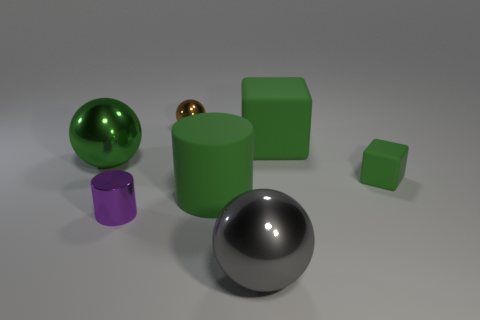There is a large matte thing behind the small green block; what color is it?
Give a very brief answer. Green. What material is the ball in front of the big shiny thing that is behind the green rubber cylinder?
Ensure brevity in your answer.  Metal. Are there any metallic cylinders of the same size as the brown ball?
Ensure brevity in your answer.  Yes. What number of things are balls that are behind the tiny purple object or objects that are right of the big green sphere?
Provide a succinct answer. 7. Is the size of the matte object that is behind the small green object the same as the purple metal cylinder that is to the left of the gray metallic thing?
Provide a succinct answer. No. There is a big metallic ball right of the brown object; are there any green rubber things that are left of it?
Provide a succinct answer. Yes. There is a large green matte cylinder; what number of green cubes are in front of it?
Provide a succinct answer. 0. How many other objects are there of the same color as the tiny ball?
Your response must be concise. 0. Is the number of large rubber cubes to the left of the purple metal thing less than the number of cubes left of the small rubber cube?
Make the answer very short. Yes. How many things are either green things that are right of the gray metal sphere or tiny purple cylinders?
Provide a succinct answer. 3. 